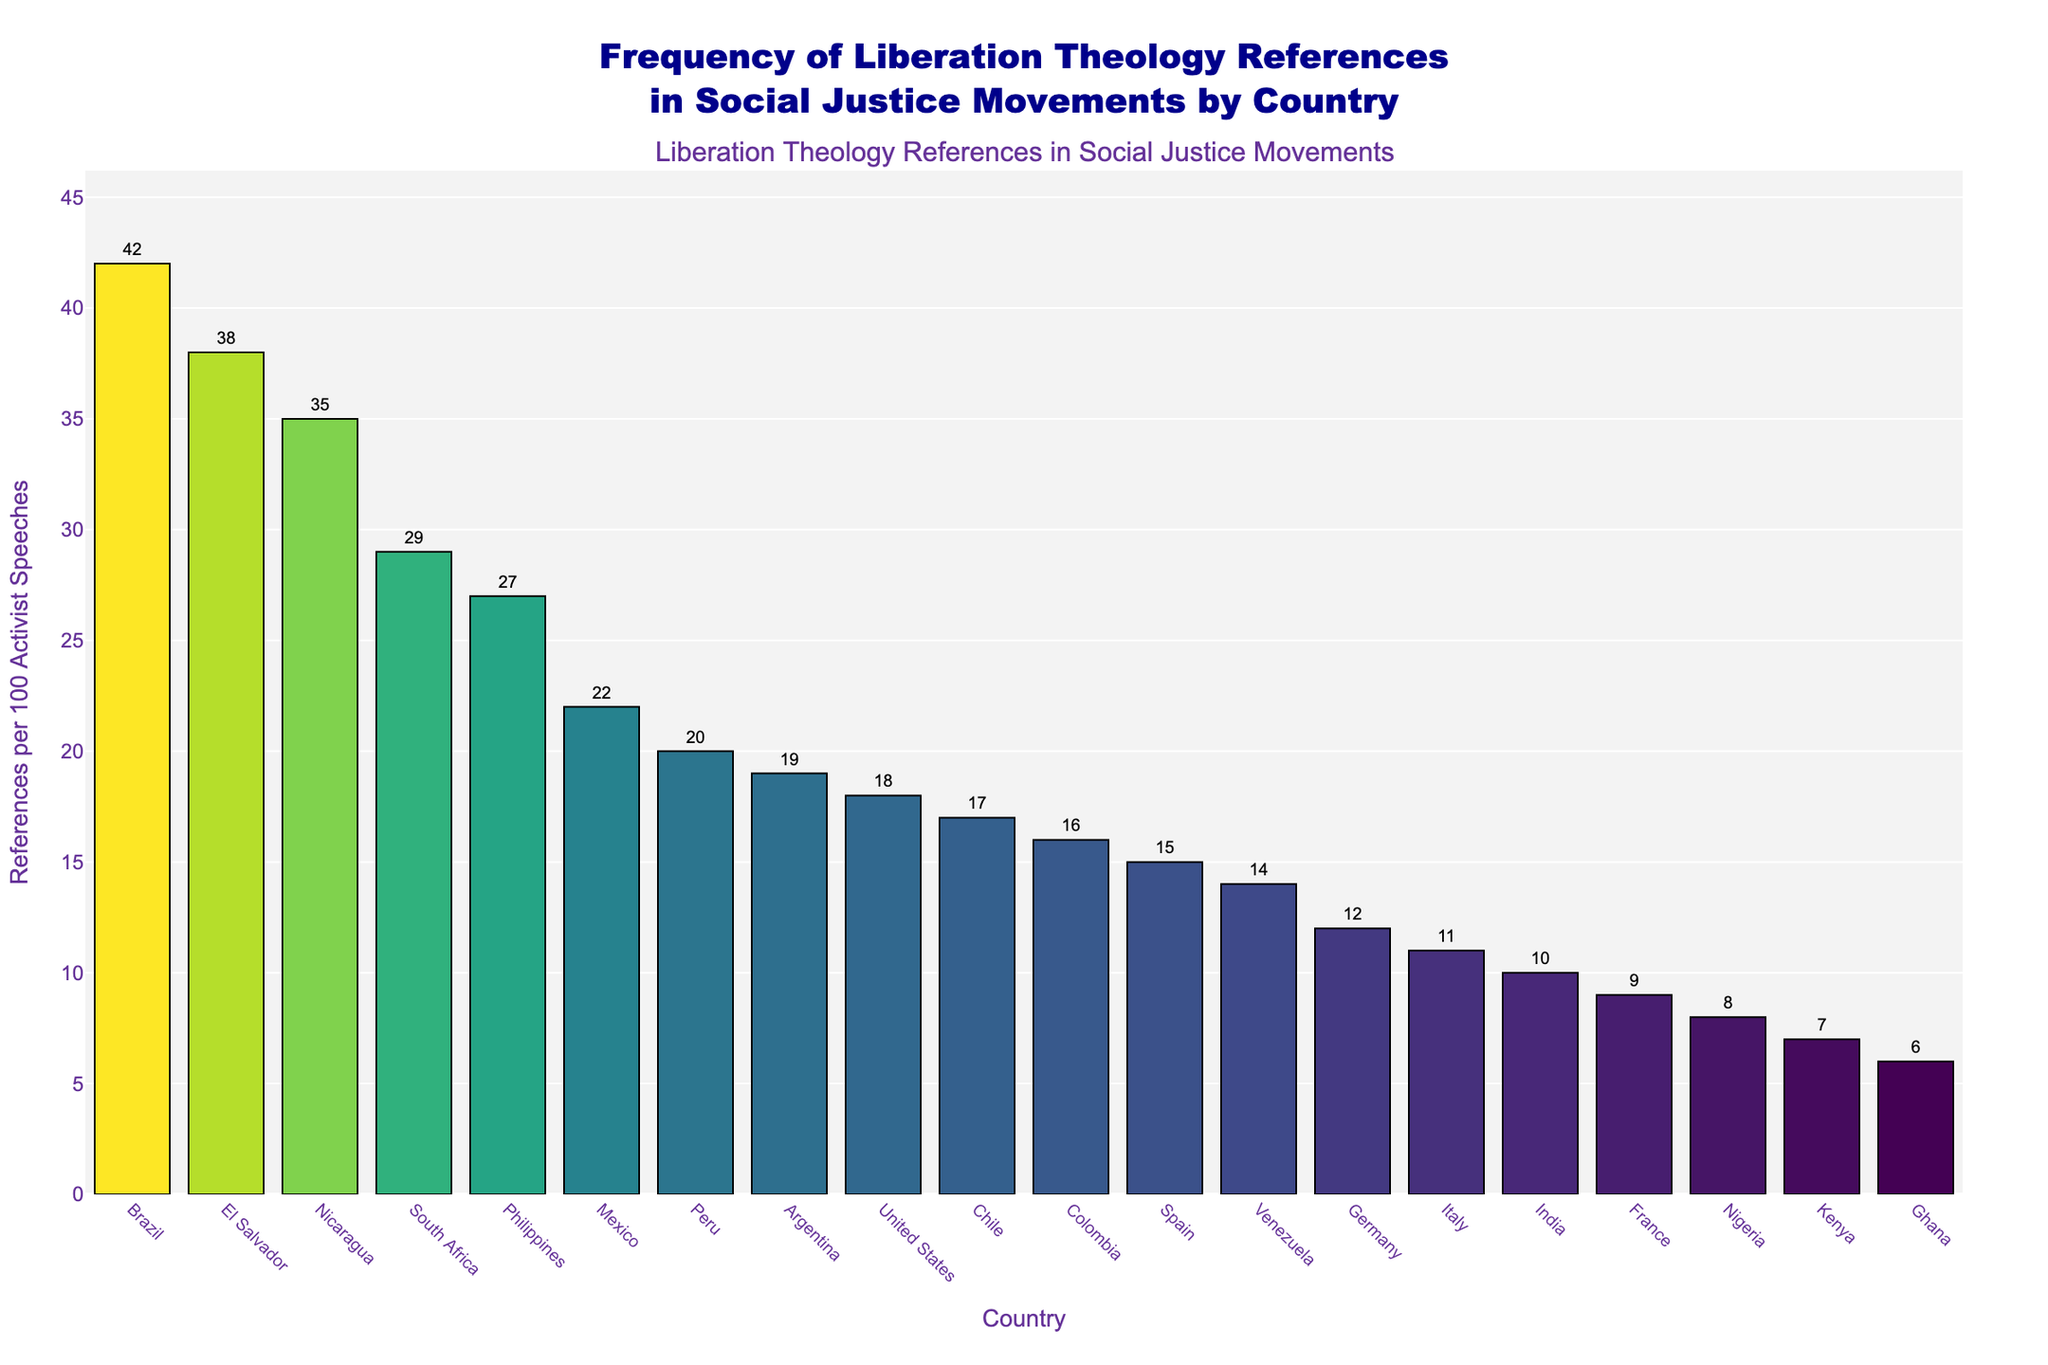Which country has the highest frequency of Liberation Theology references in activist speeches? The highest bar is the one representing Brazil, which indicates it has the highest frequency of references.
Answer: Brazil Which country has the lowest frequency of Liberation Theology references in activist speeches? The shortest bar belongs to Ghana, indicating it has the lowest frequency of references.
Answer: Ghana What is the difference in frequency of Liberation Theology references between Brazil and the United States? The frequency for Brazil is 42 and for the United States is 18. The difference is 42 - 18 = 24.
Answer: 24 How many countries have a frequency of Liberation Theology references greater than 20? Count the countries with bars that extend above the value of 20 on the y-axis. Those countries are Brazil, El Salvador, Nicaragua, South Africa, Philippines, Mexico, and Peru. There are 7 in total.
Answer: 7 What is the average frequency of Liberation Theology references among Brazil, El Salvador, and Nicaragua? Find the sum of the frequencies for Brazil (42), El Salvador (38), and Nicaragua (35) which is 42 + 38 + 35 = 115. Then, divide by 3. The average is 115 / 3 ≈ 38.33.
Answer: 38.33 Which countries have a frequency of Liberation Theology references closest to 15? The bars closest to the 15 mark on the y-axis are Spain with a frequency of 15, and Germany with 12 and Colombia with 16 also quite close to 15.
Answer: Spain, Germany, Colombia What is the combined frequency of Liberation Theology references for the countries in South America? The South American countries listed are Brazil (42), Argentina (19), Peru (20), Colombia (16), Chile (17), and Venezuela (14). Add these values: 42 + 19 + 20 + 16 + 17 + 14 = 128.
Answer: 128 How does the frequency of Liberation Theology references in the Philippines compare to that of Mexico? The bar for the Philippines stands at 27, while Mexico's bar is at 22. Thus, the Philippines has a higher frequency.
Answer: Philippines is higher Is the frequency of Liberation Theology references in Italy greater than that in France? The bar for Italy is at 11, and for France, it is at 9. Therefore, Italy has a higher frequency.
Answer: Yes Which country between South Africa and India has a greater frequency of Liberation Theology references and by how much? South Africa has a frequency of 29, and India has a frequency of 10. The difference is 29 - 10 = 19.
Answer: South Africa by 19 